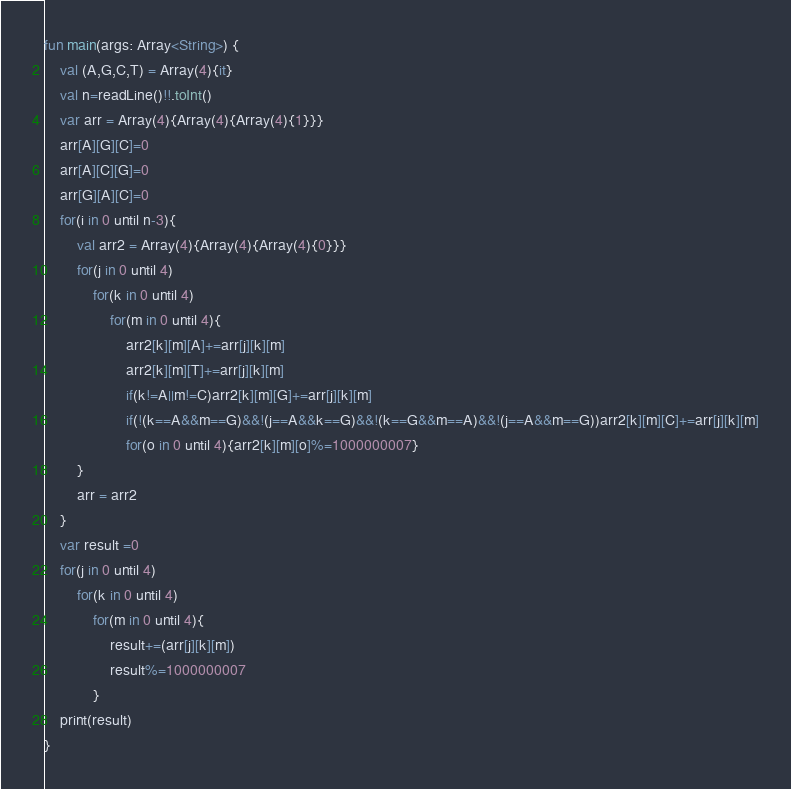<code> <loc_0><loc_0><loc_500><loc_500><_Kotlin_>fun main(args: Array<String>) {
    val (A,G,C,T) = Array(4){it}
    val n=readLine()!!.toInt()
    var arr = Array(4){Array(4){Array(4){1}}}
    arr[A][G][C]=0
    arr[A][C][G]=0
    arr[G][A][C]=0
    for(i in 0 until n-3){
        val arr2 = Array(4){Array(4){Array(4){0}}}
        for(j in 0 until 4)
            for(k in 0 until 4)
                for(m in 0 until 4){
                    arr2[k][m][A]+=arr[j][k][m]
                    arr2[k][m][T]+=arr[j][k][m]
                    if(k!=A||m!=C)arr2[k][m][G]+=arr[j][k][m]
                    if(!(k==A&&m==G)&&!(j==A&&k==G)&&!(k==G&&m==A)&&!(j==A&&m==G))arr2[k][m][C]+=arr[j][k][m]
                    for(o in 0 until 4){arr2[k][m][o]%=1000000007}
        }
        arr = arr2
    }
    var result =0
    for(j in 0 until 4)
        for(k in 0 until 4)
            for(m in 0 until 4){
                result+=(arr[j][k][m])
                result%=1000000007
            }
    print(result)
}</code> 